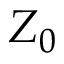<formula> <loc_0><loc_0><loc_500><loc_500>Z _ { 0 }</formula> 